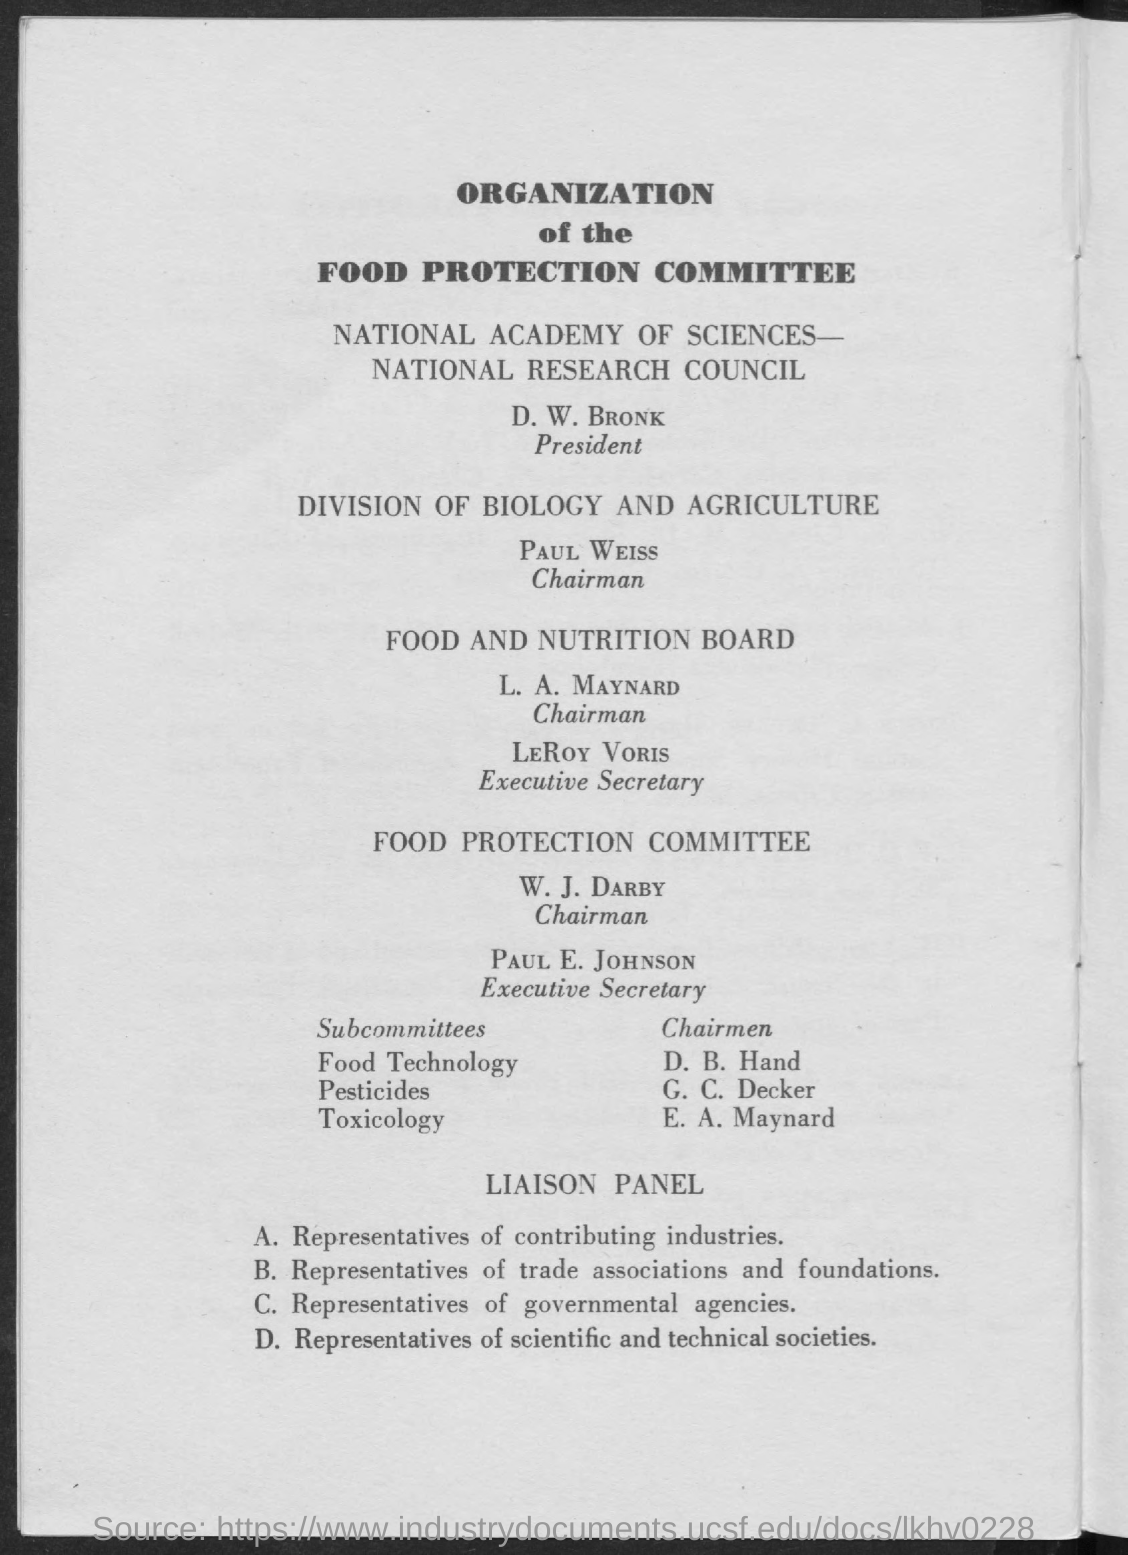Highlight a few significant elements in this photo. The chairman of the Food Projection Committee is W. J. Darby. D.B. Hand is the chairman of food technology. LeRoy Voris is the executive secretary of the Food and Nutrition Board. The chairman of the division of biology and agriculture is Paul Weiss. The person who is the chairman of toxicology is E.A. Maynard. 